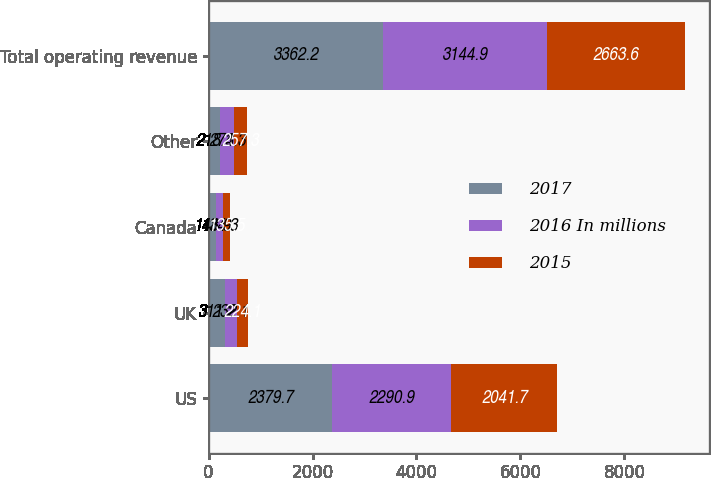Convert chart. <chart><loc_0><loc_0><loc_500><loc_500><stacked_bar_chart><ecel><fcel>US<fcel>UK<fcel>Canada<fcel>Other<fcel>Total operating revenue<nl><fcel>2017<fcel>2379.7<fcel>311.2<fcel>148.9<fcel>218.4<fcel>3362.2<nl><fcel>2016 In millions<fcel>2290.9<fcel>232.1<fcel>134.3<fcel>273.3<fcel>3144.9<nl><fcel>2015<fcel>2041.7<fcel>224.1<fcel>135.5<fcel>257.3<fcel>2663.6<nl></chart> 